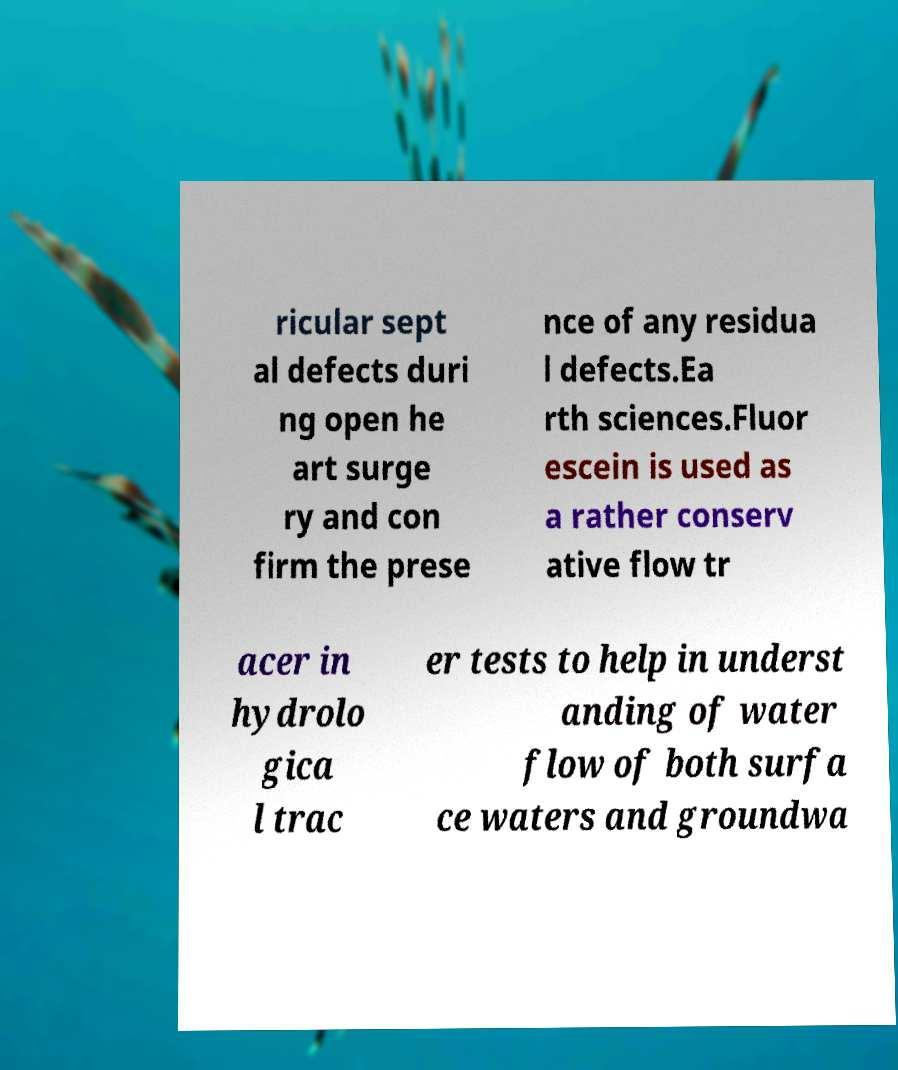Can you read and provide the text displayed in the image?This photo seems to have some interesting text. Can you extract and type it out for me? ricular sept al defects duri ng open he art surge ry and con firm the prese nce of any residua l defects.Ea rth sciences.Fluor escein is used as a rather conserv ative flow tr acer in hydrolo gica l trac er tests to help in underst anding of water flow of both surfa ce waters and groundwa 